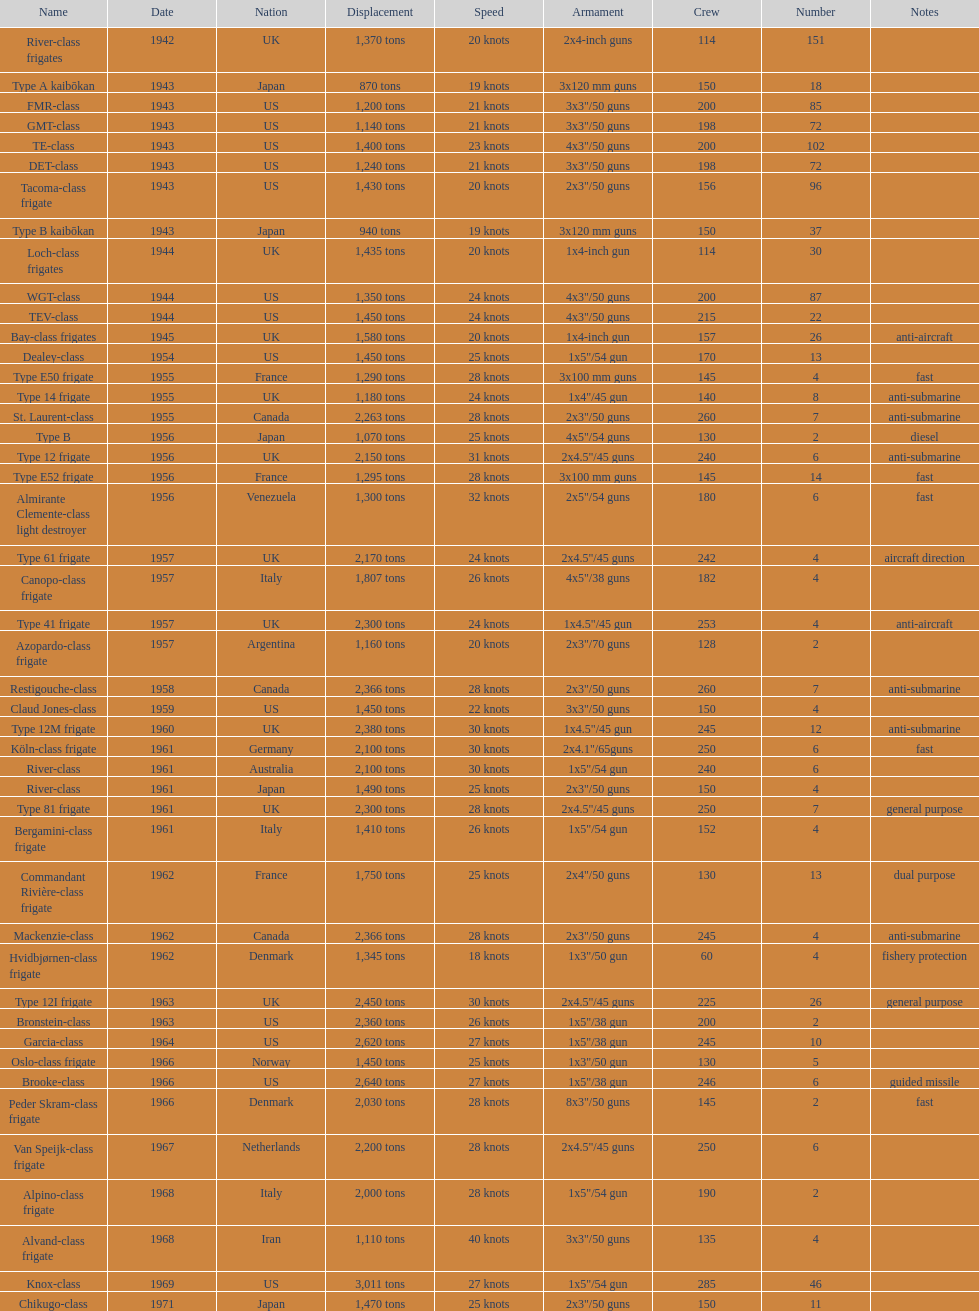What is the difference in speed for the gmt-class and the te-class? 2 knots. 